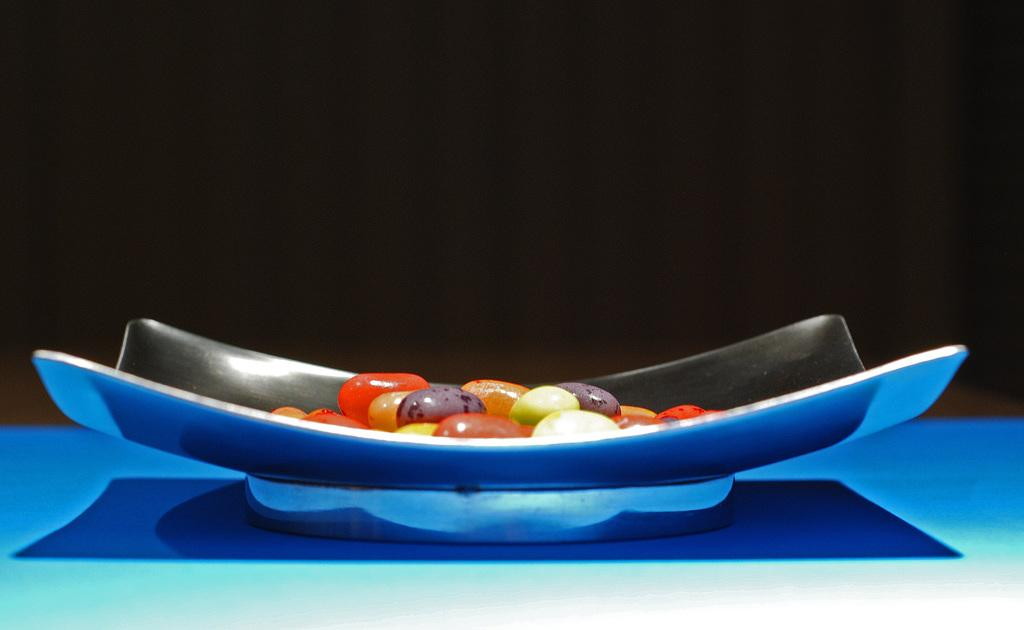What is located in the foreground of the image? There is a bowl in the foreground of the image. What can be found inside the bowl? There is an unspecified object inside the bowl. What color is the background of the image? The background of the image is black. What type of jam is being served with the berries at the dinner table in the image? There is no dinner table, jam, or berries present in the image. 